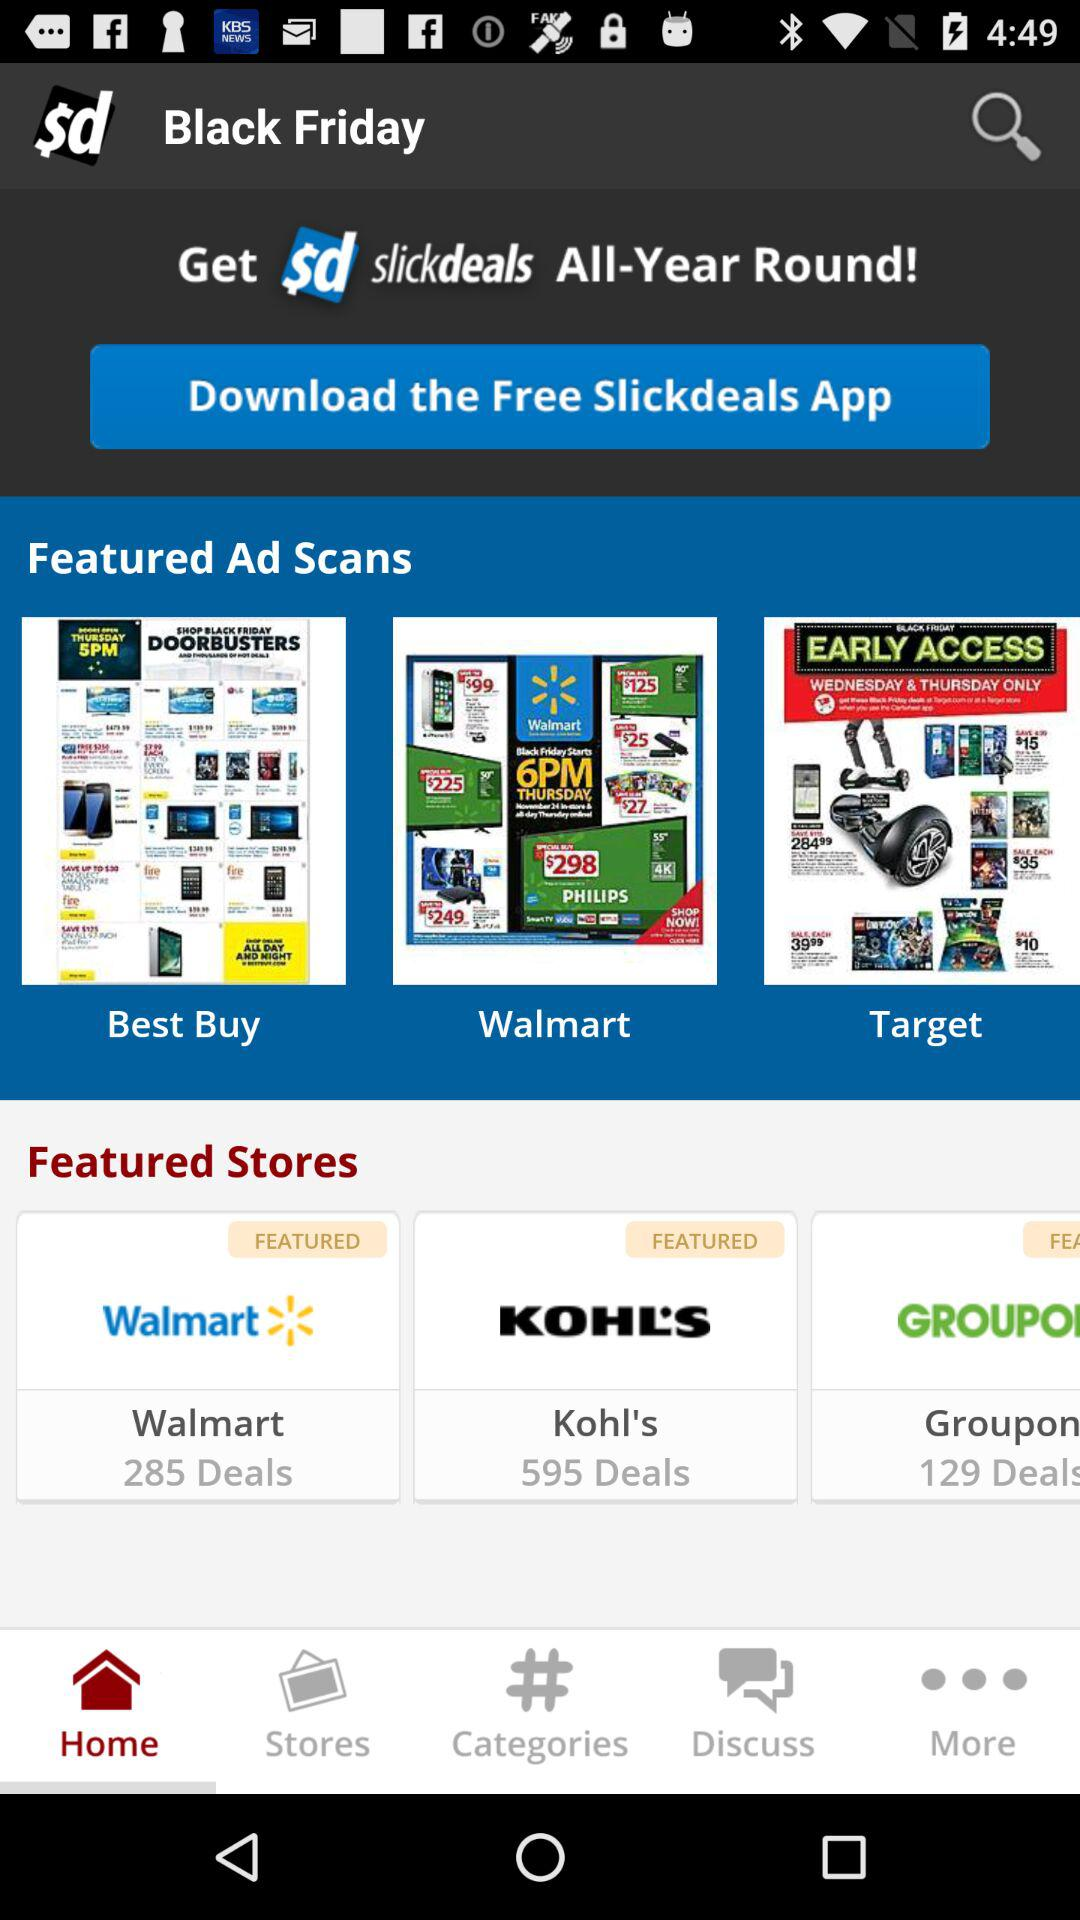What is the number of deals at "Kohl's"? The number of deals at "Kohl's" is 595. 